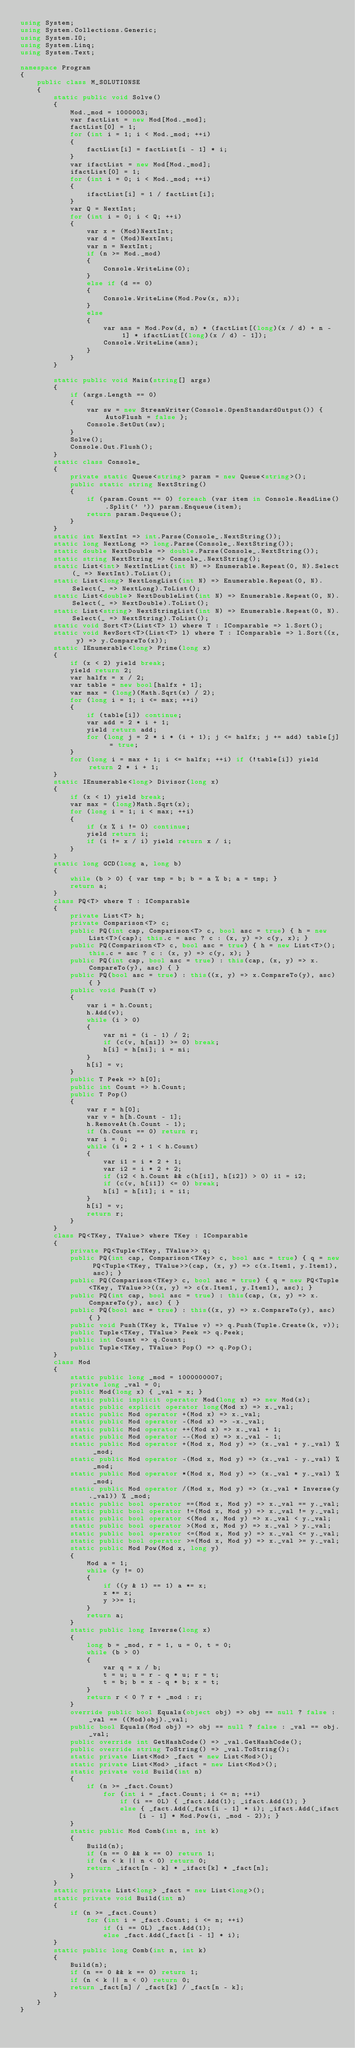<code> <loc_0><loc_0><loc_500><loc_500><_C#_>using System;
using System.Collections.Generic;
using System.IO;
using System.Linq;
using System.Text;

namespace Program
{
    public class M_SOLUTIONSE
    {
        static public void Solve()
        {
            Mod._mod = 1000003;
            var factList = new Mod[Mod._mod];
            factList[0] = 1;
            for (int i = 1; i < Mod._mod; ++i)
            {
                factList[i] = factList[i - 1] * i;
            }
            var ifactList = new Mod[Mod._mod];
            ifactList[0] = 1;
            for (int i = 0; i < Mod._mod; ++i)
            {
                ifactList[i] = 1 / factList[i];
            }
            var Q = NextInt;
            for (int i = 0; i < Q; ++i)
            {
                var x = (Mod)NextInt;
                var d = (Mod)NextInt;
                var n = NextInt;
                if (n >= Mod._mod)
                {
                    Console.WriteLine(0);
                }
                else if (d == 0)
                {
                    Console.WriteLine(Mod.Pow(x, n));
                }
                else
                {
                    var ans = Mod.Pow(d, n) * (factList[(long)(x / d) + n - 1] * ifactList[(long)(x / d) - 1]);
                    Console.WriteLine(ans);
                }
            }
        }

        static public void Main(string[] args)
        {
            if (args.Length == 0)
            {
                var sw = new StreamWriter(Console.OpenStandardOutput()) { AutoFlush = false };
                Console.SetOut(sw);
            }
            Solve();
            Console.Out.Flush();
        }
        static class Console_
        {
            private static Queue<string> param = new Queue<string>();
            public static string NextString()
            {
                if (param.Count == 0) foreach (var item in Console.ReadLine().Split(' ')) param.Enqueue(item);
                return param.Dequeue();
            }
        }
        static int NextInt => int.Parse(Console_.NextString());
        static long NextLong => long.Parse(Console_.NextString());
        static double NextDouble => double.Parse(Console_.NextString());
        static string NextString => Console_.NextString();
        static List<int> NextIntList(int N) => Enumerable.Repeat(0, N).Select(_ => NextInt).ToList();
        static List<long> NextLongList(int N) => Enumerable.Repeat(0, N).Select(_ => NextLong).ToList();
        static List<double> NextDoubleList(int N) => Enumerable.Repeat(0, N).Select(_ => NextDouble).ToList();
        static List<string> NextStringList(int N) => Enumerable.Repeat(0, N).Select(_ => NextString).ToList();
        static void Sort<T>(List<T> l) where T : IComparable => l.Sort();
        static void RevSort<T>(List<T> l) where T : IComparable => l.Sort((x, y) => y.CompareTo(x));
        static IEnumerable<long> Prime(long x)
        {
            if (x < 2) yield break;
            yield return 2;
            var halfx = x / 2;
            var table = new bool[halfx + 1];
            var max = (long)(Math.Sqrt(x) / 2);
            for (long i = 1; i <= max; ++i)
            {
                if (table[i]) continue;
                var add = 2 * i + 1;
                yield return add;
                for (long j = 2 * i * (i + 1); j <= halfx; j += add) table[j] = true;
            }
            for (long i = max + 1; i <= halfx; ++i) if (!table[i]) yield return 2 * i + 1;
        }
        static IEnumerable<long> Divisor(long x)
        {
            if (x < 1) yield break;
            var max = (long)Math.Sqrt(x);
            for (long i = 1; i < max; ++i)
            {
                if (x % i != 0) continue;
                yield return i;
                if (i != x / i) yield return x / i;
            }
        }
        static long GCD(long a, long b)
        {
            while (b > 0) { var tmp = b; b = a % b; a = tmp; }
            return a;
        }
        class PQ<T> where T : IComparable
        {
            private List<T> h;
            private Comparison<T> c;
            public PQ(int cap, Comparison<T> c, bool asc = true) { h = new List<T>(cap); this.c = asc ? c : (x, y) => c(y, x); }
            public PQ(Comparison<T> c, bool asc = true) { h = new List<T>(); this.c = asc ? c : (x, y) => c(y, x); }
            public PQ(int cap, bool asc = true) : this(cap, (x, y) => x.CompareTo(y), asc) { }
            public PQ(bool asc = true) : this((x, y) => x.CompareTo(y), asc) { }
            public void Push(T v)
            {
                var i = h.Count;
                h.Add(v);
                while (i > 0)
                {
                    var ni = (i - 1) / 2;
                    if (c(v, h[ni]) >= 0) break;
                    h[i] = h[ni]; i = ni;
                }
                h[i] = v;
            }
            public T Peek => h[0];
            public int Count => h.Count;
            public T Pop()
            {
                var r = h[0];
                var v = h[h.Count - 1];
                h.RemoveAt(h.Count - 1);
                if (h.Count == 0) return r;
                var i = 0;
                while (i * 2 + 1 < h.Count)
                {
                    var i1 = i * 2 + 1;
                    var i2 = i * 2 + 2;
                    if (i2 < h.Count && c(h[i1], h[i2]) > 0) i1 = i2;
                    if (c(v, h[i1]) <= 0) break;
                    h[i] = h[i1]; i = i1;
                }
                h[i] = v;
                return r;
            }
        }
        class PQ<TKey, TValue> where TKey : IComparable
        {
            private PQ<Tuple<TKey, TValue>> q;
            public PQ(int cap, Comparison<TKey> c, bool asc = true) { q = new PQ<Tuple<TKey, TValue>>(cap, (x, y) => c(x.Item1, y.Item1), asc); }
            public PQ(Comparison<TKey> c, bool asc = true) { q = new PQ<Tuple<TKey, TValue>>((x, y) => c(x.Item1, y.Item1), asc); }
            public PQ(int cap, bool asc = true) : this(cap, (x, y) => x.CompareTo(y), asc) { }
            public PQ(bool asc = true) : this((x, y) => x.CompareTo(y), asc) { }
            public void Push(TKey k, TValue v) => q.Push(Tuple.Create(k, v));
            public Tuple<TKey, TValue> Peek => q.Peek;
            public int Count => q.Count;
            public Tuple<TKey, TValue> Pop() => q.Pop();
        }
        class Mod
        {
            static public long _mod = 1000000007;
            private long _val = 0;
            public Mod(long x) { _val = x; }
            static public implicit operator Mod(long x) => new Mod(x);
            static public explicit operator long(Mod x) => x._val;
            static public Mod operator +(Mod x) => x._val;
            static public Mod operator -(Mod x) => -x._val;
            static public Mod operator ++(Mod x) => x._val + 1;
            static public Mod operator --(Mod x) => x._val - 1;
            static public Mod operator +(Mod x, Mod y) => (x._val + y._val) % _mod;
            static public Mod operator -(Mod x, Mod y) => (x._val - y._val) % _mod;
            static public Mod operator *(Mod x, Mod y) => (x._val * y._val) % _mod;
            static public Mod operator /(Mod x, Mod y) => (x._val * Inverse(y._val)) % _mod;
            static public bool operator ==(Mod x, Mod y) => x._val == y._val;
            static public bool operator !=(Mod x, Mod y) => x._val != y._val;
            static public bool operator <(Mod x, Mod y) => x._val < y._val;
            static public bool operator >(Mod x, Mod y) => x._val > y._val;
            static public bool operator <=(Mod x, Mod y) => x._val <= y._val;
            static public bool operator >=(Mod x, Mod y) => x._val >= y._val;
            static public Mod Pow(Mod x, long y)
            {
                Mod a = 1;
                while (y != 0)
                {
                    if ((y & 1) == 1) a *= x;
                    x *= x;
                    y >>= 1;
                }
                return a;
            }
            static public long Inverse(long x)
            {
                long b = _mod, r = 1, u = 0, t = 0;
                while (b > 0)
                {
                    var q = x / b;
                    t = u; u = r - q * u; r = t;
                    t = b; b = x - q * b; x = t;
                }
                return r < 0 ? r + _mod : r;
            }
            override public bool Equals(object obj) => obj == null ? false : _val == ((Mod)obj)._val;
            public bool Equals(Mod obj) => obj == null ? false : _val == obj._val;
            public override int GetHashCode() => _val.GetHashCode();
            public override string ToString() => _val.ToString();
            static private List<Mod> _fact = new List<Mod>();
            static private List<Mod> _ifact = new List<Mod>();
            static private void Build(int n)
            {
                if (n >= _fact.Count)
                    for (int i = _fact.Count; i <= n; ++i)
                        if (i == 0L) { _fact.Add(1); _ifact.Add(1); }
                        else { _fact.Add(_fact[i - 1] * i); _ifact.Add(_ifact[i - 1] * Mod.Pow(i, _mod - 2)); }
            }
            static public Mod Comb(int n, int k)
            {
                Build(n);
                if (n == 0 && k == 0) return 1;
                if (n < k || n < 0) return 0;
                return _ifact[n - k] * _ifact[k] * _fact[n];
            }
        }
        static private List<long> _fact = new List<long>();
        static private void Build(int n)
        {
            if (n >= _fact.Count)
                for (int i = _fact.Count; i <= n; ++i)
                    if (i == 0L) _fact.Add(1);
                    else _fact.Add(_fact[i - 1] * i);
        }
        static public long Comb(int n, int k)
        {
            Build(n);
            if (n == 0 && k == 0) return 1;
            if (n < k || n < 0) return 0;
            return _fact[n] / _fact[k] / _fact[n - k];
        }
    }
}
</code> 